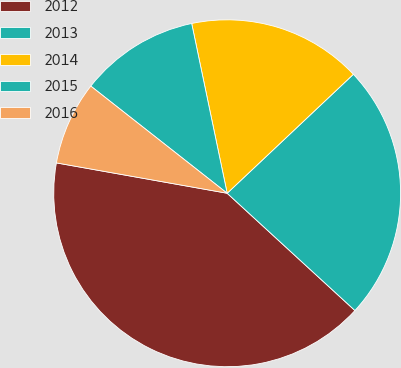Convert chart. <chart><loc_0><loc_0><loc_500><loc_500><pie_chart><fcel>2012<fcel>2013<fcel>2014<fcel>2015<fcel>2016<nl><fcel>40.98%<fcel>23.85%<fcel>16.25%<fcel>11.12%<fcel>7.8%<nl></chart> 